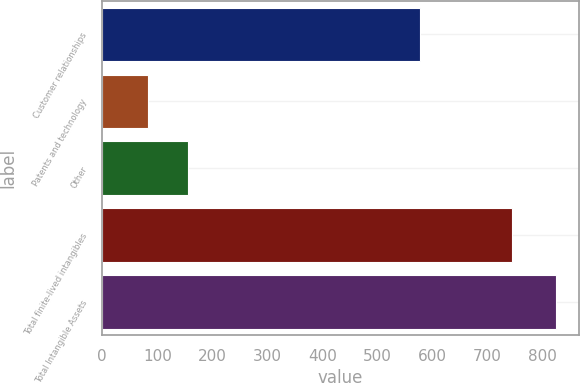<chart> <loc_0><loc_0><loc_500><loc_500><bar_chart><fcel>Customer relationships<fcel>Patents and technology<fcel>Other<fcel>Total finite-lived intangibles<fcel>Total Intangible Assets<nl><fcel>577.8<fcel>82.4<fcel>156.58<fcel>744.9<fcel>824.2<nl></chart> 